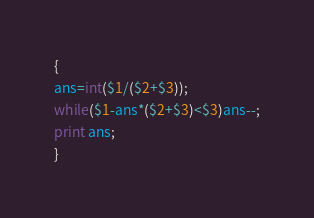Convert code to text. <code><loc_0><loc_0><loc_500><loc_500><_Awk_>{
ans=int($1/($2+$3));
while($1-ans*($2+$3)<$3)ans--;
print ans;
}</code> 